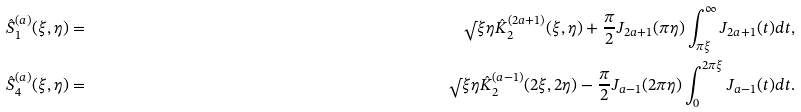Convert formula to latex. <formula><loc_0><loc_0><loc_500><loc_500>\hat { S } ^ { ( a ) } _ { 1 } ( \xi , \eta ) & = & \sqrt { } { \xi } \eta \hat { K } _ { 2 } ^ { ( 2 a + 1 ) } ( \xi , \eta ) + \frac { \pi } { 2 } J _ { 2 a + 1 } ( \pi \eta ) \int _ { \pi \xi } ^ { \infty } J _ { 2 a + 1 } ( t ) d t , \\ \hat { S } ^ { ( a ) } _ { 4 } ( \xi , \eta ) & = & \sqrt { } { \xi } \eta \hat { K } _ { 2 } ^ { ( a - 1 ) } ( 2 \xi , 2 \eta ) - \frac { \pi } { 2 } J _ { a - 1 } ( 2 \pi \eta ) \int _ { 0 } ^ { 2 \pi \xi } J _ { a - 1 } ( t ) d t .</formula> 